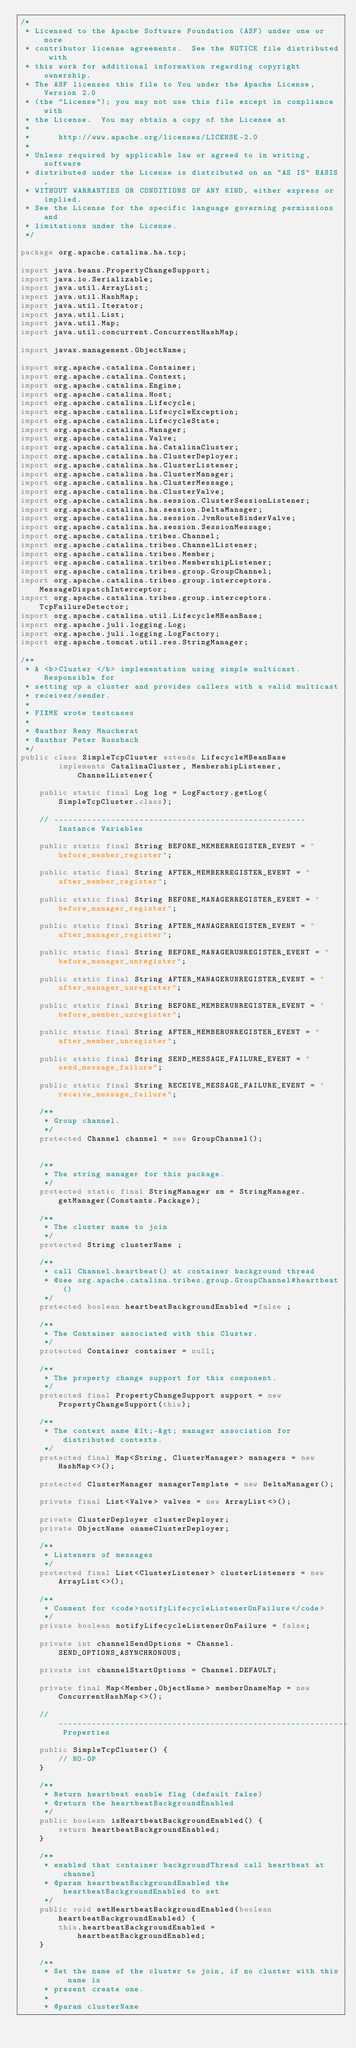Convert code to text. <code><loc_0><loc_0><loc_500><loc_500><_Java_>/*
 * Licensed to the Apache Software Foundation (ASF) under one or more
 * contributor license agreements.  See the NOTICE file distributed with
 * this work for additional information regarding copyright ownership.
 * The ASF licenses this file to You under the Apache License, Version 2.0
 * (the "License"); you may not use this file except in compliance with
 * the License.  You may obtain a copy of the License at
 *
 *      http://www.apache.org/licenses/LICENSE-2.0
 *
 * Unless required by applicable law or agreed to in writing, software
 * distributed under the License is distributed on an "AS IS" BASIS,
 * WITHOUT WARRANTIES OR CONDITIONS OF ANY KIND, either express or implied.
 * See the License for the specific language governing permissions and
 * limitations under the License.
 */

package org.apache.catalina.ha.tcp;

import java.beans.PropertyChangeSupport;
import java.io.Serializable;
import java.util.ArrayList;
import java.util.HashMap;
import java.util.Iterator;
import java.util.List;
import java.util.Map;
import java.util.concurrent.ConcurrentHashMap;

import javax.management.ObjectName;

import org.apache.catalina.Container;
import org.apache.catalina.Context;
import org.apache.catalina.Engine;
import org.apache.catalina.Host;
import org.apache.catalina.Lifecycle;
import org.apache.catalina.LifecycleException;
import org.apache.catalina.LifecycleState;
import org.apache.catalina.Manager;
import org.apache.catalina.Valve;
import org.apache.catalina.ha.CatalinaCluster;
import org.apache.catalina.ha.ClusterDeployer;
import org.apache.catalina.ha.ClusterListener;
import org.apache.catalina.ha.ClusterManager;
import org.apache.catalina.ha.ClusterMessage;
import org.apache.catalina.ha.ClusterValve;
import org.apache.catalina.ha.session.ClusterSessionListener;
import org.apache.catalina.ha.session.DeltaManager;
import org.apache.catalina.ha.session.JvmRouteBinderValve;
import org.apache.catalina.ha.session.SessionMessage;
import org.apache.catalina.tribes.Channel;
import org.apache.catalina.tribes.ChannelListener;
import org.apache.catalina.tribes.Member;
import org.apache.catalina.tribes.MembershipListener;
import org.apache.catalina.tribes.group.GroupChannel;
import org.apache.catalina.tribes.group.interceptors.MessageDispatchInterceptor;
import org.apache.catalina.tribes.group.interceptors.TcpFailureDetector;
import org.apache.catalina.util.LifecycleMBeanBase;
import org.apache.juli.logging.Log;
import org.apache.juli.logging.LogFactory;
import org.apache.tomcat.util.res.StringManager;

/**
 * A <b>Cluster </b> implementation using simple multicast. Responsible for
 * setting up a cluster and provides callers with a valid multicast
 * receiver/sender.
 *
 * FIXME wrote testcases
 *
 * @author Remy Maucherat
 * @author Peter Rossbach
 */
public class SimpleTcpCluster extends LifecycleMBeanBase
        implements CatalinaCluster, MembershipListener, ChannelListener{

    public static final Log log = LogFactory.getLog(SimpleTcpCluster.class);

    // ----------------------------------------------------- Instance Variables

    public static final String BEFORE_MEMBERREGISTER_EVENT = "before_member_register";

    public static final String AFTER_MEMBERREGISTER_EVENT = "after_member_register";

    public static final String BEFORE_MANAGERREGISTER_EVENT = "before_manager_register";

    public static final String AFTER_MANAGERREGISTER_EVENT = "after_manager_register";

    public static final String BEFORE_MANAGERUNREGISTER_EVENT = "before_manager_unregister";

    public static final String AFTER_MANAGERUNREGISTER_EVENT = "after_manager_unregister";

    public static final String BEFORE_MEMBERUNREGISTER_EVENT = "before_member_unregister";

    public static final String AFTER_MEMBERUNREGISTER_EVENT = "after_member_unregister";

    public static final String SEND_MESSAGE_FAILURE_EVENT = "send_message_failure";

    public static final String RECEIVE_MESSAGE_FAILURE_EVENT = "receive_message_failure";

    /**
     * Group channel.
     */
    protected Channel channel = new GroupChannel();


    /**
     * The string manager for this package.
     */
    protected static final StringManager sm = StringManager.getManager(Constants.Package);

    /**
     * The cluster name to join
     */
    protected String clusterName ;

    /**
     * call Channel.heartbeat() at container background thread
     * @see org.apache.catalina.tribes.group.GroupChannel#heartbeat()
     */
    protected boolean heartbeatBackgroundEnabled =false ;

    /**
     * The Container associated with this Cluster.
     */
    protected Container container = null;

    /**
     * The property change support for this component.
     */
    protected final PropertyChangeSupport support = new PropertyChangeSupport(this);

    /**
     * The context name &lt;-&gt; manager association for distributed contexts.
     */
    protected final Map<String, ClusterManager> managers = new HashMap<>();

    protected ClusterManager managerTemplate = new DeltaManager();

    private final List<Valve> valves = new ArrayList<>();

    private ClusterDeployer clusterDeployer;
    private ObjectName onameClusterDeployer;

    /**
     * Listeners of messages
     */
    protected final List<ClusterListener> clusterListeners = new ArrayList<>();

    /**
     * Comment for <code>notifyLifecycleListenerOnFailure</code>
     */
    private boolean notifyLifecycleListenerOnFailure = false;

    private int channelSendOptions = Channel.SEND_OPTIONS_ASYNCHRONOUS;

    private int channelStartOptions = Channel.DEFAULT;

    private final Map<Member,ObjectName> memberOnameMap = new ConcurrentHashMap<>();

    // ------------------------------------------------------------- Properties

    public SimpleTcpCluster() {
        // NO-OP
    }

    /**
     * Return heartbeat enable flag (default false)
     * @return the heartbeatBackgroundEnabled
     */
    public boolean isHeartbeatBackgroundEnabled() {
        return heartbeatBackgroundEnabled;
    }

    /**
     * enabled that container backgroundThread call heartbeat at channel
     * @param heartbeatBackgroundEnabled the heartbeatBackgroundEnabled to set
     */
    public void setHeartbeatBackgroundEnabled(boolean heartbeatBackgroundEnabled) {
        this.heartbeatBackgroundEnabled = heartbeatBackgroundEnabled;
    }

    /**
     * Set the name of the cluster to join, if no cluster with this name is
     * present create one.
     *
     * @param clusterName</code> 